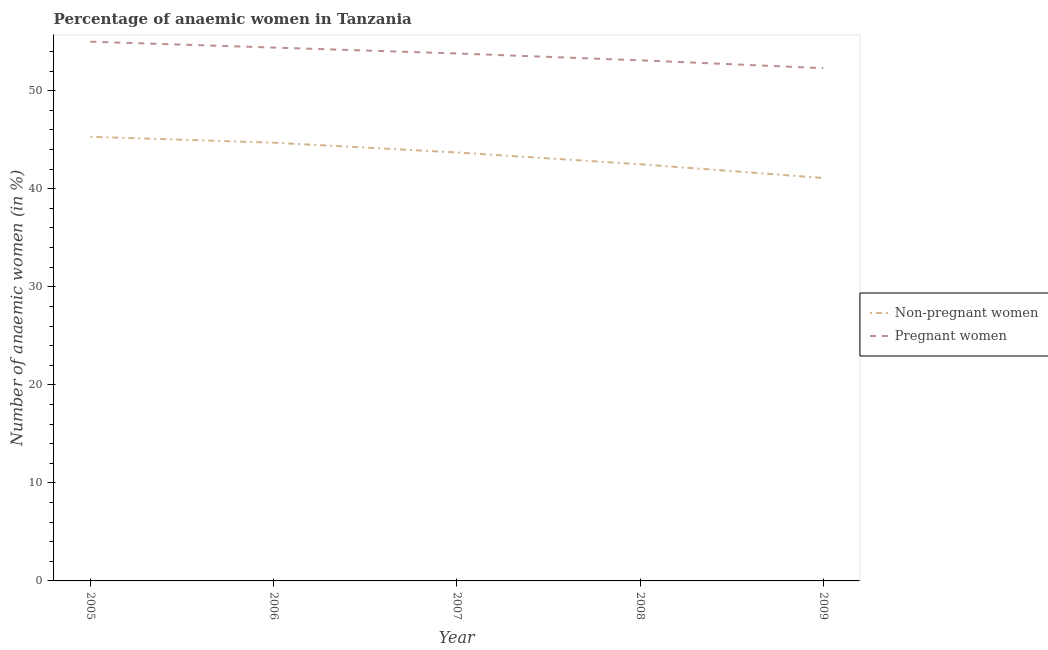How many different coloured lines are there?
Keep it short and to the point. 2. Does the line corresponding to percentage of non-pregnant anaemic women intersect with the line corresponding to percentage of pregnant anaemic women?
Ensure brevity in your answer.  No. What is the percentage of pregnant anaemic women in 2005?
Your answer should be compact. 55. Across all years, what is the minimum percentage of pregnant anaemic women?
Offer a very short reply. 52.3. In which year was the percentage of pregnant anaemic women maximum?
Provide a succinct answer. 2005. What is the total percentage of non-pregnant anaemic women in the graph?
Provide a succinct answer. 217.3. What is the difference between the percentage of non-pregnant anaemic women in 2005 and that in 2009?
Ensure brevity in your answer.  4.2. What is the difference between the percentage of pregnant anaemic women in 2007 and the percentage of non-pregnant anaemic women in 2009?
Your answer should be compact. 12.7. What is the average percentage of pregnant anaemic women per year?
Give a very brief answer. 53.72. In the year 2008, what is the difference between the percentage of pregnant anaemic women and percentage of non-pregnant anaemic women?
Keep it short and to the point. 10.6. What is the ratio of the percentage of pregnant anaemic women in 2005 to that in 2009?
Your answer should be compact. 1.05. Is the percentage of non-pregnant anaemic women in 2006 less than that in 2008?
Keep it short and to the point. No. Is the difference between the percentage of pregnant anaemic women in 2006 and 2007 greater than the difference between the percentage of non-pregnant anaemic women in 2006 and 2007?
Ensure brevity in your answer.  No. What is the difference between the highest and the second highest percentage of non-pregnant anaemic women?
Make the answer very short. 0.6. What is the difference between the highest and the lowest percentage of pregnant anaemic women?
Your response must be concise. 2.7. In how many years, is the percentage of non-pregnant anaemic women greater than the average percentage of non-pregnant anaemic women taken over all years?
Your response must be concise. 3. Is the percentage of non-pregnant anaemic women strictly greater than the percentage of pregnant anaemic women over the years?
Keep it short and to the point. No. How many lines are there?
Provide a succinct answer. 2. How many years are there in the graph?
Give a very brief answer. 5. Does the graph contain any zero values?
Provide a short and direct response. No. Where does the legend appear in the graph?
Give a very brief answer. Center right. What is the title of the graph?
Your response must be concise. Percentage of anaemic women in Tanzania. What is the label or title of the X-axis?
Ensure brevity in your answer.  Year. What is the label or title of the Y-axis?
Make the answer very short. Number of anaemic women (in %). What is the Number of anaemic women (in %) in Non-pregnant women in 2005?
Offer a very short reply. 45.3. What is the Number of anaemic women (in %) of Pregnant women in 2005?
Provide a short and direct response. 55. What is the Number of anaemic women (in %) in Non-pregnant women in 2006?
Make the answer very short. 44.7. What is the Number of anaemic women (in %) of Pregnant women in 2006?
Ensure brevity in your answer.  54.4. What is the Number of anaemic women (in %) of Non-pregnant women in 2007?
Offer a terse response. 43.7. What is the Number of anaemic women (in %) in Pregnant women in 2007?
Offer a terse response. 53.8. What is the Number of anaemic women (in %) in Non-pregnant women in 2008?
Provide a short and direct response. 42.5. What is the Number of anaemic women (in %) of Pregnant women in 2008?
Your answer should be very brief. 53.1. What is the Number of anaemic women (in %) of Non-pregnant women in 2009?
Give a very brief answer. 41.1. What is the Number of anaemic women (in %) in Pregnant women in 2009?
Provide a short and direct response. 52.3. Across all years, what is the maximum Number of anaemic women (in %) of Non-pregnant women?
Your response must be concise. 45.3. Across all years, what is the minimum Number of anaemic women (in %) in Non-pregnant women?
Provide a succinct answer. 41.1. Across all years, what is the minimum Number of anaemic women (in %) in Pregnant women?
Your answer should be very brief. 52.3. What is the total Number of anaemic women (in %) in Non-pregnant women in the graph?
Offer a terse response. 217.3. What is the total Number of anaemic women (in %) in Pregnant women in the graph?
Offer a terse response. 268.6. What is the difference between the Number of anaemic women (in %) in Pregnant women in 2005 and that in 2006?
Offer a terse response. 0.6. What is the difference between the Number of anaemic women (in %) in Non-pregnant women in 2005 and that in 2007?
Your answer should be very brief. 1.6. What is the difference between the Number of anaemic women (in %) of Pregnant women in 2005 and that in 2007?
Offer a very short reply. 1.2. What is the difference between the Number of anaemic women (in %) in Non-pregnant women in 2005 and that in 2008?
Ensure brevity in your answer.  2.8. What is the difference between the Number of anaemic women (in %) in Non-pregnant women in 2005 and that in 2009?
Offer a terse response. 4.2. What is the difference between the Number of anaemic women (in %) in Non-pregnant women in 2006 and that in 2007?
Ensure brevity in your answer.  1. What is the difference between the Number of anaemic women (in %) of Non-pregnant women in 2006 and that in 2008?
Provide a succinct answer. 2.2. What is the difference between the Number of anaemic women (in %) in Non-pregnant women in 2007 and that in 2008?
Make the answer very short. 1.2. What is the difference between the Number of anaemic women (in %) of Pregnant women in 2007 and that in 2009?
Your answer should be very brief. 1.5. What is the difference between the Number of anaemic women (in %) of Pregnant women in 2008 and that in 2009?
Your answer should be very brief. 0.8. What is the difference between the Number of anaemic women (in %) of Non-pregnant women in 2006 and the Number of anaemic women (in %) of Pregnant women in 2009?
Give a very brief answer. -7.6. What is the difference between the Number of anaemic women (in %) of Non-pregnant women in 2008 and the Number of anaemic women (in %) of Pregnant women in 2009?
Your answer should be very brief. -9.8. What is the average Number of anaemic women (in %) of Non-pregnant women per year?
Offer a terse response. 43.46. What is the average Number of anaemic women (in %) of Pregnant women per year?
Ensure brevity in your answer.  53.72. In the year 2005, what is the difference between the Number of anaemic women (in %) in Non-pregnant women and Number of anaemic women (in %) in Pregnant women?
Offer a very short reply. -9.7. In the year 2007, what is the difference between the Number of anaemic women (in %) of Non-pregnant women and Number of anaemic women (in %) of Pregnant women?
Provide a succinct answer. -10.1. In the year 2008, what is the difference between the Number of anaemic women (in %) of Non-pregnant women and Number of anaemic women (in %) of Pregnant women?
Your answer should be compact. -10.6. In the year 2009, what is the difference between the Number of anaemic women (in %) in Non-pregnant women and Number of anaemic women (in %) in Pregnant women?
Ensure brevity in your answer.  -11.2. What is the ratio of the Number of anaemic women (in %) of Non-pregnant women in 2005 to that in 2006?
Provide a succinct answer. 1.01. What is the ratio of the Number of anaemic women (in %) of Pregnant women in 2005 to that in 2006?
Keep it short and to the point. 1.01. What is the ratio of the Number of anaemic women (in %) in Non-pregnant women in 2005 to that in 2007?
Make the answer very short. 1.04. What is the ratio of the Number of anaemic women (in %) of Pregnant women in 2005 to that in 2007?
Offer a terse response. 1.02. What is the ratio of the Number of anaemic women (in %) in Non-pregnant women in 2005 to that in 2008?
Offer a terse response. 1.07. What is the ratio of the Number of anaemic women (in %) of Pregnant women in 2005 to that in 2008?
Your response must be concise. 1.04. What is the ratio of the Number of anaemic women (in %) of Non-pregnant women in 2005 to that in 2009?
Provide a short and direct response. 1.1. What is the ratio of the Number of anaemic women (in %) in Pregnant women in 2005 to that in 2009?
Your answer should be very brief. 1.05. What is the ratio of the Number of anaemic women (in %) of Non-pregnant women in 2006 to that in 2007?
Give a very brief answer. 1.02. What is the ratio of the Number of anaemic women (in %) of Pregnant women in 2006 to that in 2007?
Make the answer very short. 1.01. What is the ratio of the Number of anaemic women (in %) in Non-pregnant women in 2006 to that in 2008?
Provide a succinct answer. 1.05. What is the ratio of the Number of anaemic women (in %) of Pregnant women in 2006 to that in 2008?
Provide a short and direct response. 1.02. What is the ratio of the Number of anaemic women (in %) in Non-pregnant women in 2006 to that in 2009?
Your response must be concise. 1.09. What is the ratio of the Number of anaemic women (in %) in Pregnant women in 2006 to that in 2009?
Keep it short and to the point. 1.04. What is the ratio of the Number of anaemic women (in %) in Non-pregnant women in 2007 to that in 2008?
Make the answer very short. 1.03. What is the ratio of the Number of anaemic women (in %) in Pregnant women in 2007 to that in 2008?
Offer a terse response. 1.01. What is the ratio of the Number of anaemic women (in %) in Non-pregnant women in 2007 to that in 2009?
Your response must be concise. 1.06. What is the ratio of the Number of anaemic women (in %) of Pregnant women in 2007 to that in 2009?
Your answer should be very brief. 1.03. What is the ratio of the Number of anaemic women (in %) of Non-pregnant women in 2008 to that in 2009?
Your answer should be very brief. 1.03. What is the ratio of the Number of anaemic women (in %) in Pregnant women in 2008 to that in 2009?
Keep it short and to the point. 1.02. What is the difference between the highest and the second highest Number of anaemic women (in %) of Non-pregnant women?
Your answer should be compact. 0.6. 